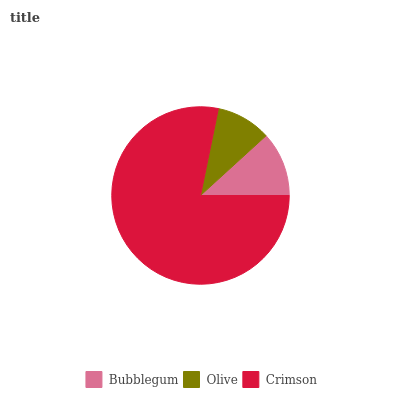Is Olive the minimum?
Answer yes or no. Yes. Is Crimson the maximum?
Answer yes or no. Yes. Is Crimson the minimum?
Answer yes or no. No. Is Olive the maximum?
Answer yes or no. No. Is Crimson greater than Olive?
Answer yes or no. Yes. Is Olive less than Crimson?
Answer yes or no. Yes. Is Olive greater than Crimson?
Answer yes or no. No. Is Crimson less than Olive?
Answer yes or no. No. Is Bubblegum the high median?
Answer yes or no. Yes. Is Bubblegum the low median?
Answer yes or no. Yes. Is Crimson the high median?
Answer yes or no. No. Is Olive the low median?
Answer yes or no. No. 